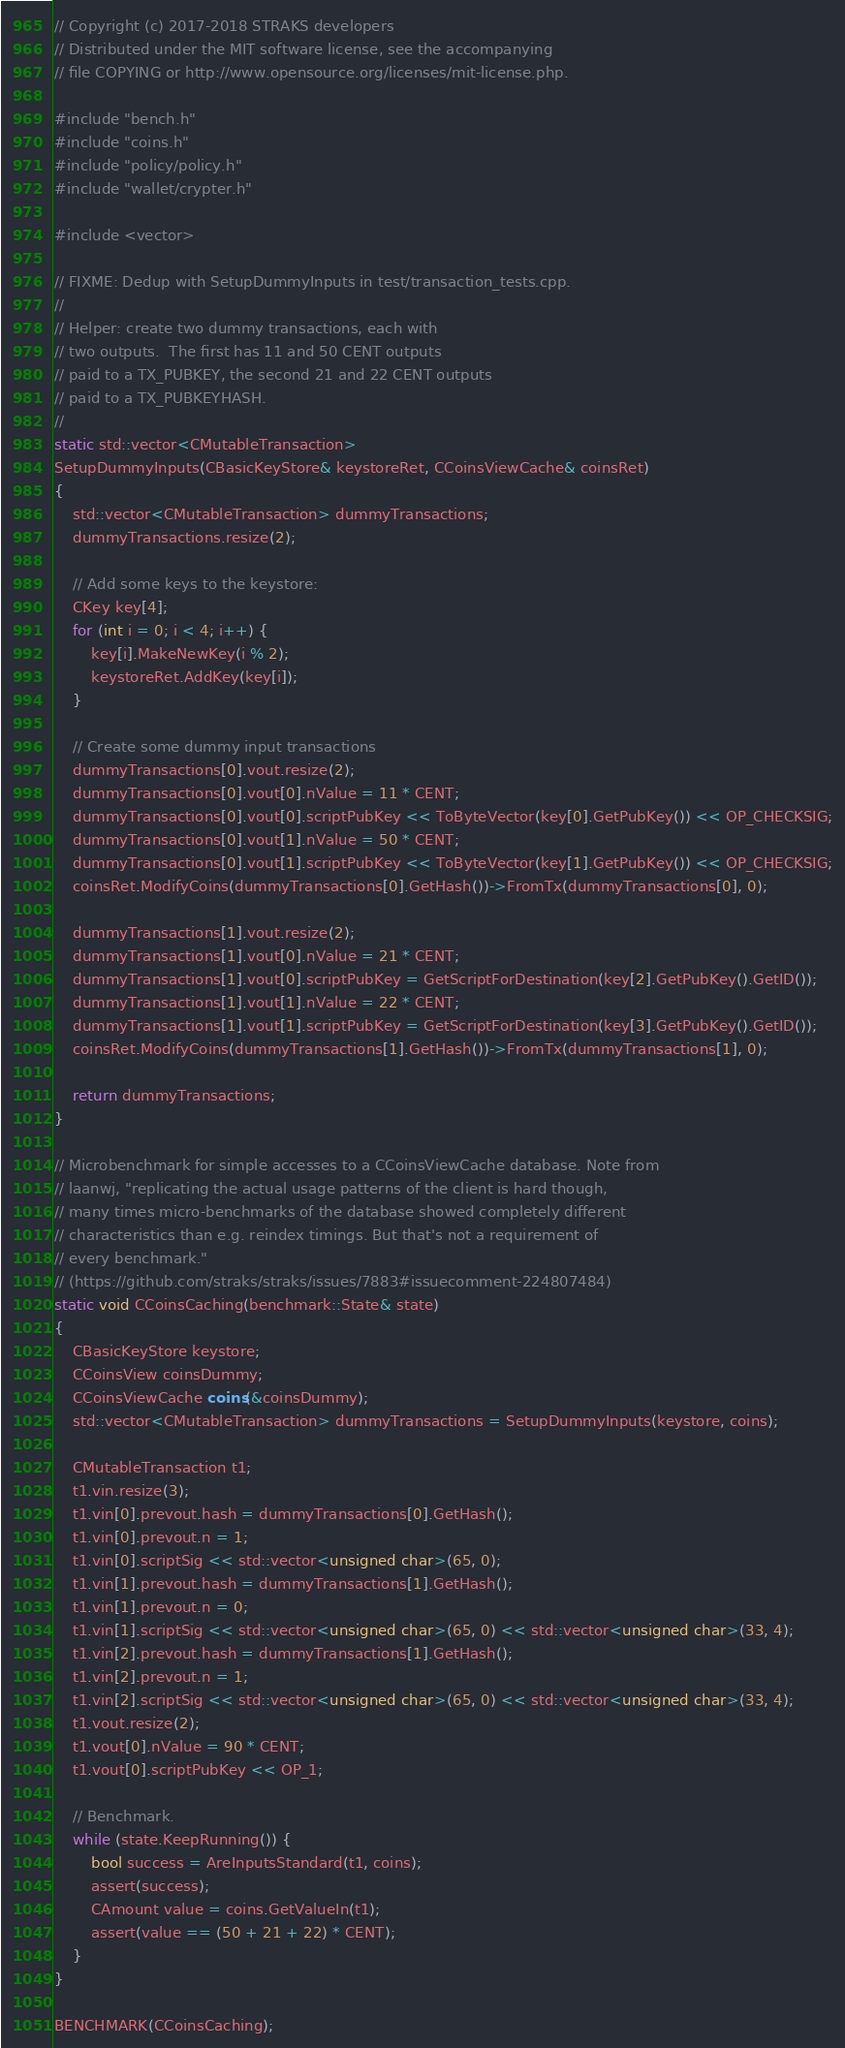Convert code to text. <code><loc_0><loc_0><loc_500><loc_500><_C++_>// Copyright (c) 2017-2018 STRAKS developers
// Distributed under the MIT software license, see the accompanying
// file COPYING or http://www.opensource.org/licenses/mit-license.php.

#include "bench.h"
#include "coins.h"
#include "policy/policy.h"
#include "wallet/crypter.h"

#include <vector>

// FIXME: Dedup with SetupDummyInputs in test/transaction_tests.cpp.
//
// Helper: create two dummy transactions, each with
// two outputs.  The first has 11 and 50 CENT outputs
// paid to a TX_PUBKEY, the second 21 and 22 CENT outputs
// paid to a TX_PUBKEYHASH.
//
static std::vector<CMutableTransaction>
SetupDummyInputs(CBasicKeyStore& keystoreRet, CCoinsViewCache& coinsRet)
{
    std::vector<CMutableTransaction> dummyTransactions;
    dummyTransactions.resize(2);

    // Add some keys to the keystore:
    CKey key[4];
    for (int i = 0; i < 4; i++) {
        key[i].MakeNewKey(i % 2);
        keystoreRet.AddKey(key[i]);
    }

    // Create some dummy input transactions
    dummyTransactions[0].vout.resize(2);
    dummyTransactions[0].vout[0].nValue = 11 * CENT;
    dummyTransactions[0].vout[0].scriptPubKey << ToByteVector(key[0].GetPubKey()) << OP_CHECKSIG;
    dummyTransactions[0].vout[1].nValue = 50 * CENT;
    dummyTransactions[0].vout[1].scriptPubKey << ToByteVector(key[1].GetPubKey()) << OP_CHECKSIG;
    coinsRet.ModifyCoins(dummyTransactions[0].GetHash())->FromTx(dummyTransactions[0], 0);

    dummyTransactions[1].vout.resize(2);
    dummyTransactions[1].vout[0].nValue = 21 * CENT;
    dummyTransactions[1].vout[0].scriptPubKey = GetScriptForDestination(key[2].GetPubKey().GetID());
    dummyTransactions[1].vout[1].nValue = 22 * CENT;
    dummyTransactions[1].vout[1].scriptPubKey = GetScriptForDestination(key[3].GetPubKey().GetID());
    coinsRet.ModifyCoins(dummyTransactions[1].GetHash())->FromTx(dummyTransactions[1], 0);

    return dummyTransactions;
}

// Microbenchmark for simple accesses to a CCoinsViewCache database. Note from
// laanwj, "replicating the actual usage patterns of the client is hard though,
// many times micro-benchmarks of the database showed completely different
// characteristics than e.g. reindex timings. But that's not a requirement of
// every benchmark."
// (https://github.com/straks/straks/issues/7883#issuecomment-224807484)
static void CCoinsCaching(benchmark::State& state)
{
    CBasicKeyStore keystore;
    CCoinsView coinsDummy;
    CCoinsViewCache coins(&coinsDummy);
    std::vector<CMutableTransaction> dummyTransactions = SetupDummyInputs(keystore, coins);

    CMutableTransaction t1;
    t1.vin.resize(3);
    t1.vin[0].prevout.hash = dummyTransactions[0].GetHash();
    t1.vin[0].prevout.n = 1;
    t1.vin[0].scriptSig << std::vector<unsigned char>(65, 0);
    t1.vin[1].prevout.hash = dummyTransactions[1].GetHash();
    t1.vin[1].prevout.n = 0;
    t1.vin[1].scriptSig << std::vector<unsigned char>(65, 0) << std::vector<unsigned char>(33, 4);
    t1.vin[2].prevout.hash = dummyTransactions[1].GetHash();
    t1.vin[2].prevout.n = 1;
    t1.vin[2].scriptSig << std::vector<unsigned char>(65, 0) << std::vector<unsigned char>(33, 4);
    t1.vout.resize(2);
    t1.vout[0].nValue = 90 * CENT;
    t1.vout[0].scriptPubKey << OP_1;

    // Benchmark.
    while (state.KeepRunning()) {
        bool success = AreInputsStandard(t1, coins);
        assert(success);
        CAmount value = coins.GetValueIn(t1);
        assert(value == (50 + 21 + 22) * CENT);
    }
}

BENCHMARK(CCoinsCaching);
</code> 